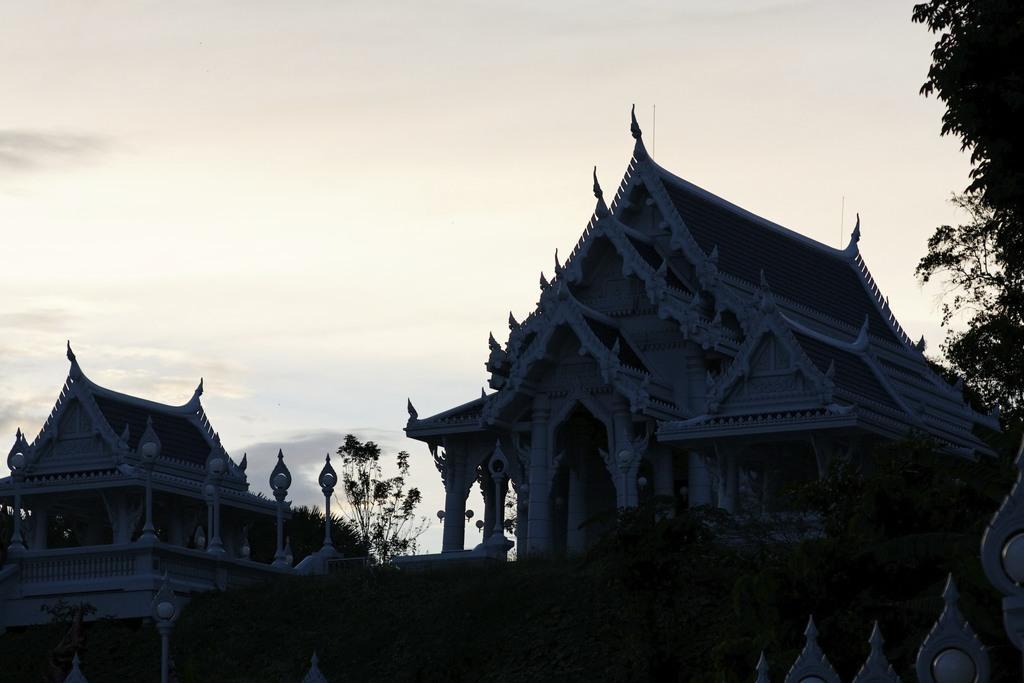In one or two sentences, can you explain what this image depicts? In the picture we can see architecture buildings which is dark and we can see trees and in the background, we can see the sky with clouds. 